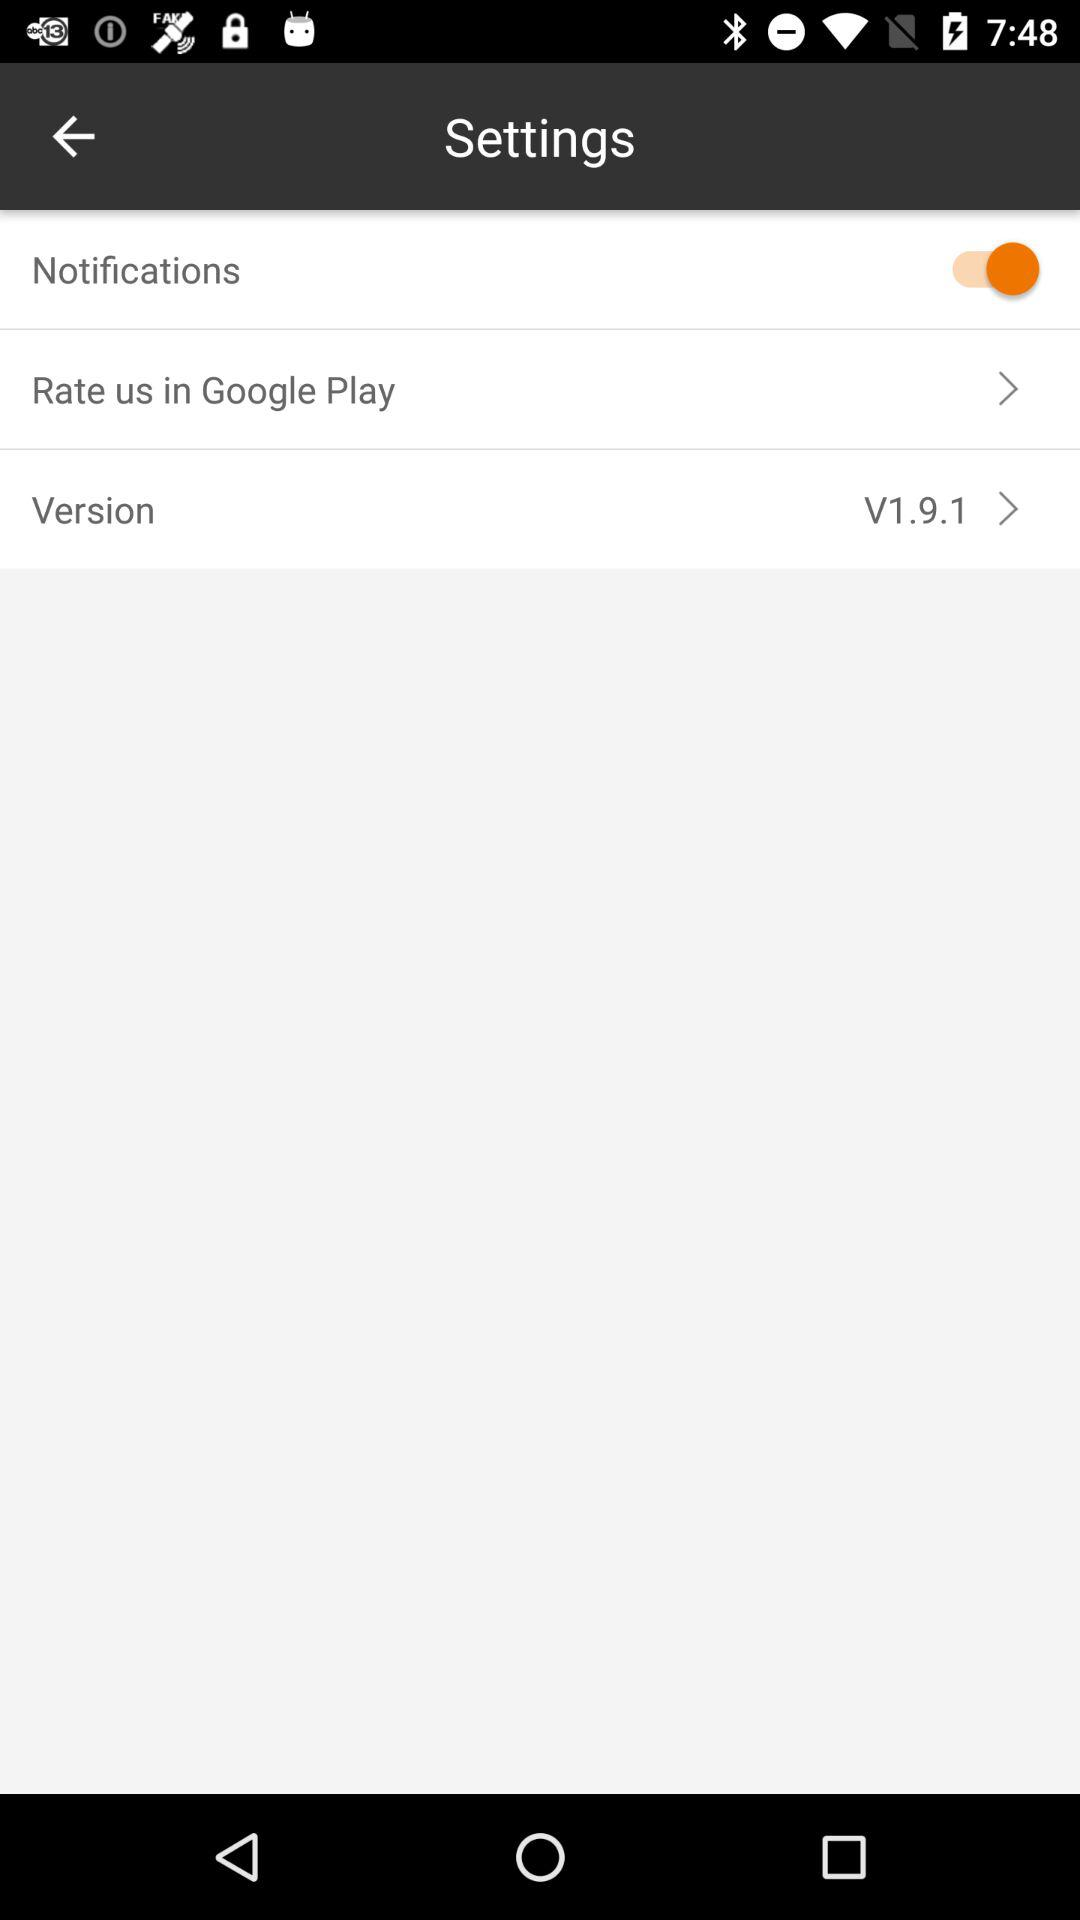What is the status of "Notifications"? The status is "on". 